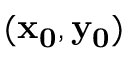Convert formula to latex. <formula><loc_0><loc_0><loc_500><loc_500>( x _ { 0 } , y _ { 0 } )</formula> 